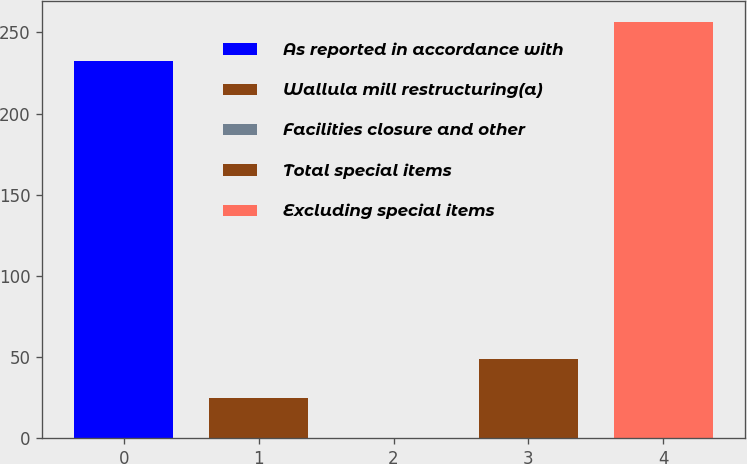<chart> <loc_0><loc_0><loc_500><loc_500><bar_chart><fcel>As reported in accordance with<fcel>Wallula mill restructuring(a)<fcel>Facilities closure and other<fcel>Total special items<fcel>Excluding special items<nl><fcel>232.5<fcel>24.71<fcel>0.5<fcel>48.92<fcel>256.71<nl></chart> 